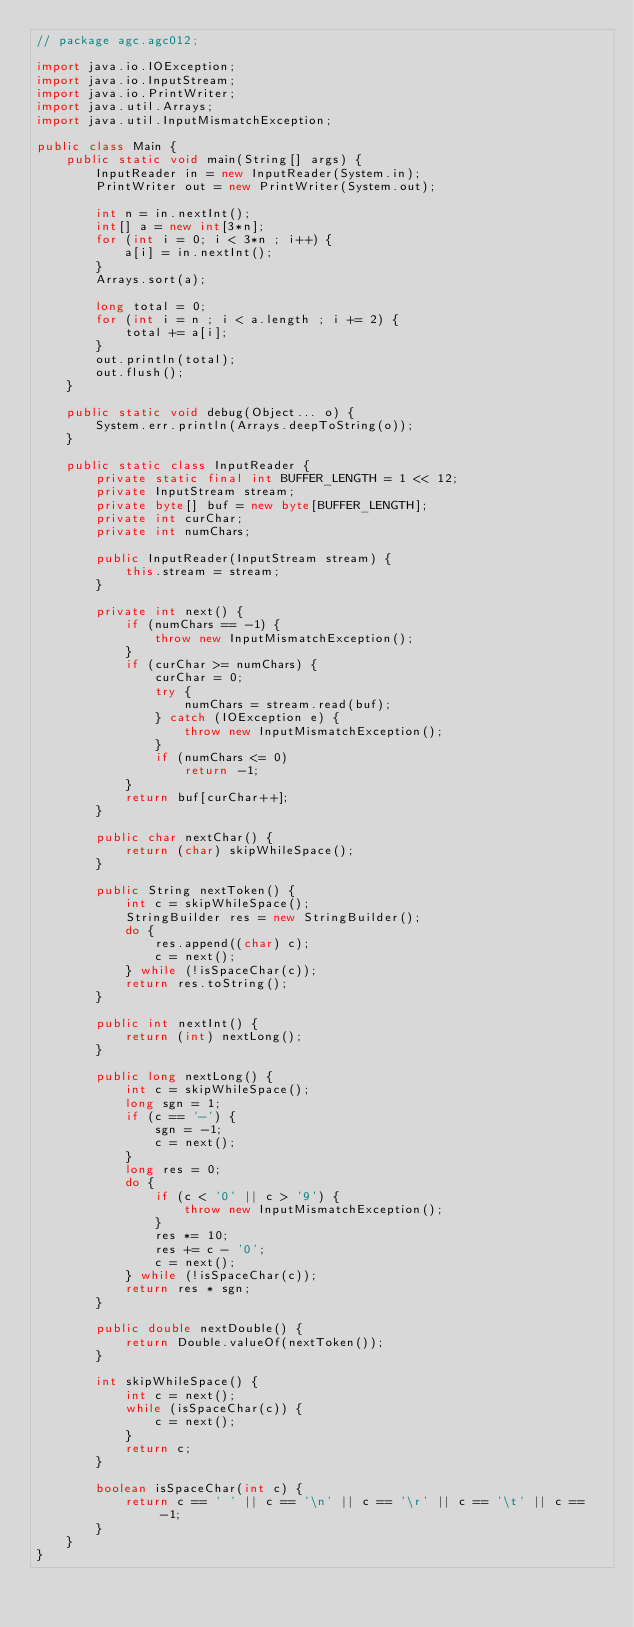Convert code to text. <code><loc_0><loc_0><loc_500><loc_500><_Java_>// package agc.agc012;

import java.io.IOException;
import java.io.InputStream;
import java.io.PrintWriter;
import java.util.Arrays;
import java.util.InputMismatchException;

public class Main {
    public static void main(String[] args) {
        InputReader in = new InputReader(System.in);
        PrintWriter out = new PrintWriter(System.out);

        int n = in.nextInt();
        int[] a = new int[3*n];
        for (int i = 0; i < 3*n ; i++) {
            a[i] = in.nextInt();
        }
        Arrays.sort(a);

        long total = 0;
        for (int i = n ; i < a.length ; i += 2) {
            total += a[i];
        }
        out.println(total);
        out.flush();
    }

    public static void debug(Object... o) {
        System.err.println(Arrays.deepToString(o));
    }

    public static class InputReader {
        private static final int BUFFER_LENGTH = 1 << 12;
        private InputStream stream;
        private byte[] buf = new byte[BUFFER_LENGTH];
        private int curChar;
        private int numChars;

        public InputReader(InputStream stream) {
            this.stream = stream;
        }

        private int next() {
            if (numChars == -1) {
                throw new InputMismatchException();
            }
            if (curChar >= numChars) {
                curChar = 0;
                try {
                    numChars = stream.read(buf);
                } catch (IOException e) {
                    throw new InputMismatchException();
                }
                if (numChars <= 0)
                    return -1;
            }
            return buf[curChar++];
        }

        public char nextChar() {
            return (char) skipWhileSpace();
        }

        public String nextToken() {
            int c = skipWhileSpace();
            StringBuilder res = new StringBuilder();
            do {
                res.append((char) c);
                c = next();
            } while (!isSpaceChar(c));
            return res.toString();
        }

        public int nextInt() {
            return (int) nextLong();
        }

        public long nextLong() {
            int c = skipWhileSpace();
            long sgn = 1;
            if (c == '-') {
                sgn = -1;
                c = next();
            }
            long res = 0;
            do {
                if (c < '0' || c > '9') {
                    throw new InputMismatchException();
                }
                res *= 10;
                res += c - '0';
                c = next();
            } while (!isSpaceChar(c));
            return res * sgn;
        }

        public double nextDouble() {
            return Double.valueOf(nextToken());
        }

        int skipWhileSpace() {
            int c = next();
            while (isSpaceChar(c)) {
                c = next();
            }
            return c;
        }

        boolean isSpaceChar(int c) {
            return c == ' ' || c == '\n' || c == '\r' || c == '\t' || c == -1;
        }
    }
}</code> 